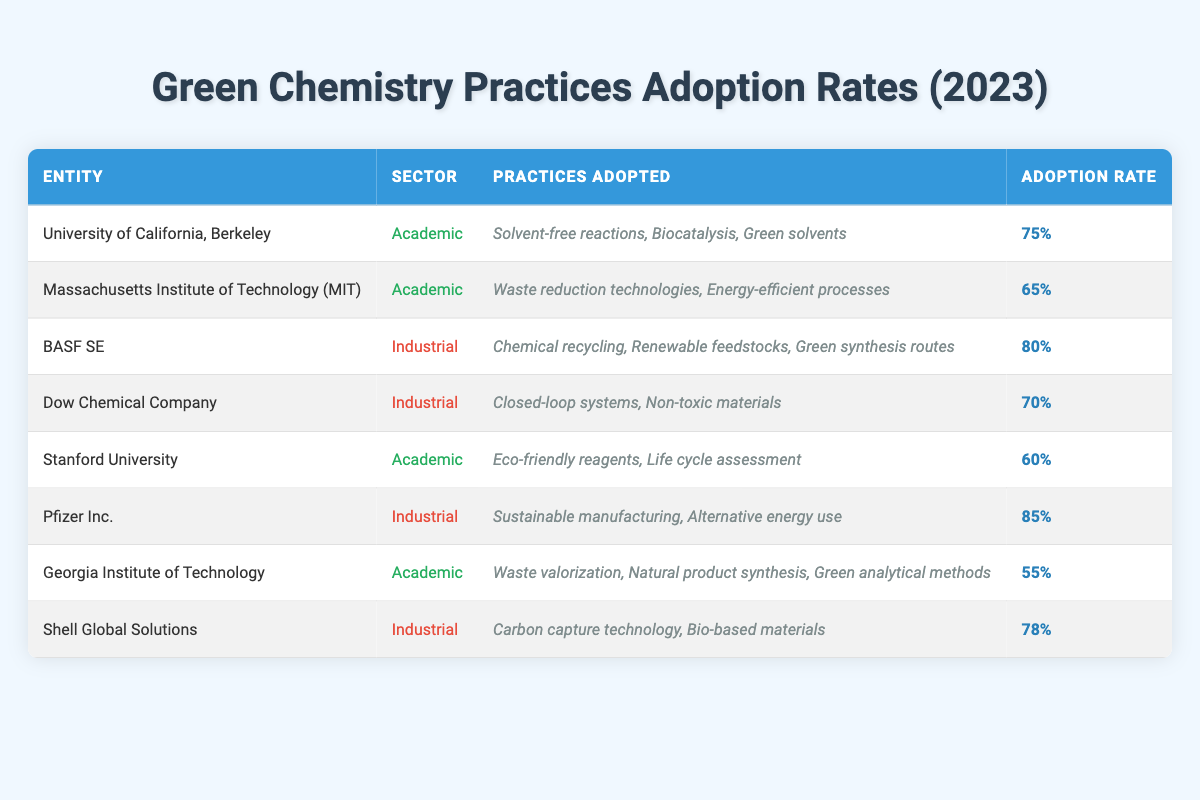What is the highest adoption rate among the entities listed? The table shows adoption rates for multiple entities. By reviewing the 'Adoption Rate' column, Pfizer Inc. has the highest rate of 85%.
Answer: 85% Which academic entity has the lowest adoption rate for green chemistry practices? Looking at the 'Adoption Rate' in the academic sector, Georgia Institute of Technology has the lowest rate at 55%, compared to Stanford University at 60% and MIT at 65%.
Answer: Georgia Institute of Technology How many industrial entities have an adoption rate above 75%? BASF SE (80%), and Pfizer Inc. (85%) both have adoption rates above 75%. Counting these gives us a total of 2 industrial entities fitting this criterion.
Answer: 2 What is the average adoption rate of green chemistry practices among the academic entities? The academic entities and their adoption rates are Berkeley (75%), MIT (65%), Stanford (60%), and Georgia Institute of Technology (55%). The average is calculated as (75 + 65 + 60 + 55) / 4 = 63.75.
Answer: 63.75 Is it true that more green chemistry practices were adopted by industrial labs than by academic labs? By comparing the maximum adoption rates: 85% (Pfizer Inc.) in industrial vs. 75% (University of California, Berkeley) in academic, we see industrial labs generally have higher rates. Hence, the statement holds true.
Answer: Yes Which industrial entity has an adoption rate closest to 75%? Reviewing the table, Dow Chemical Company has an adoption rate of 70%, which is closest to 75%, as other industrial entities either exceed it or have lower rates.
Answer: Dow Chemical Company How many total green chemistry practices were listed for the University of California, Berkeley and BASF SE combined? The practices adopted by Berkeley are 3 (solvent-free reactions, biocatalysis, green solvents) and BASF SE has 3 (chemical recycling, renewable feedstocks, green synthesis routes). Adding these gives 3 + 3 = 6 practices in total.
Answer: 6 Are there any entities that adopted the same number of green chemistry practices? By reviewing the counts, both BASF SE and Dow Chemical Company adopted 3 practices, while all academic ones have varied counts. Thus, yes, they both have 3 practices.
Answer: Yes 